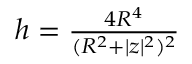<formula> <loc_0><loc_0><loc_500><loc_500>\begin{array} { r } { h = \frac { 4 R ^ { 4 } } { ( R ^ { 2 } + | z | ^ { 2 } ) ^ { 2 } } } \end{array}</formula> 